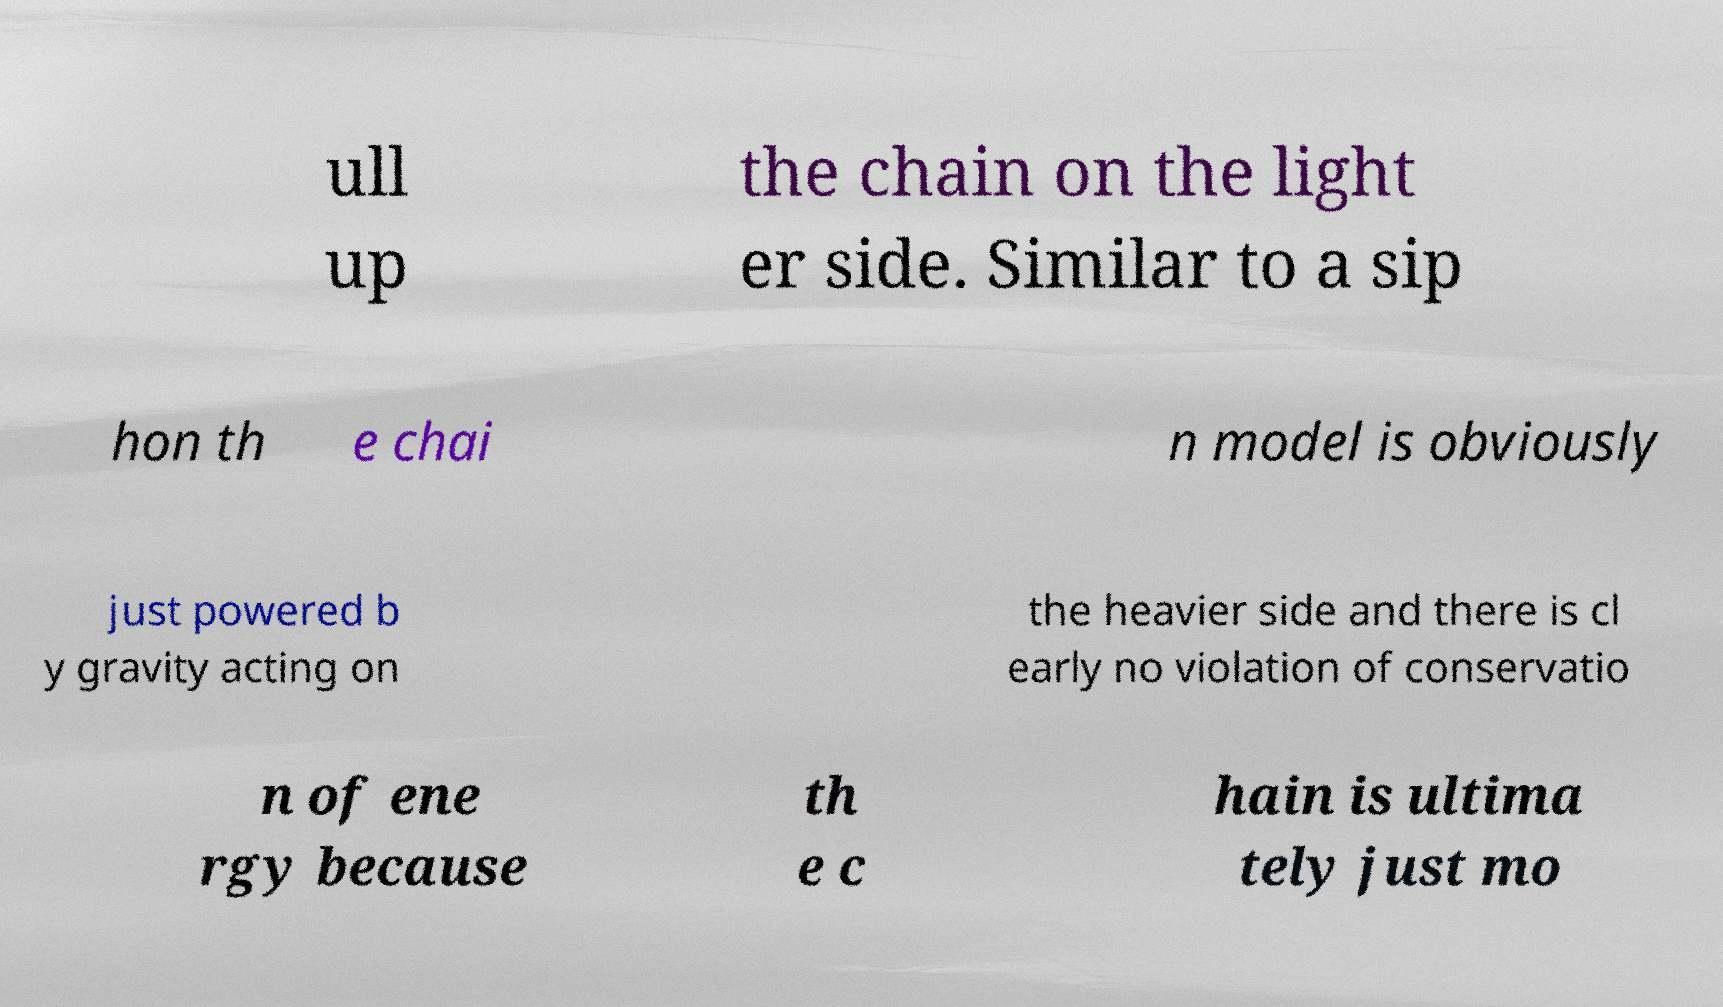What messages or text are displayed in this image? I need them in a readable, typed format. ull up the chain on the light er side. Similar to a sip hon th e chai n model is obviously just powered b y gravity acting on the heavier side and there is cl early no violation of conservatio n of ene rgy because th e c hain is ultima tely just mo 